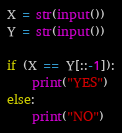Convert code to text. <code><loc_0><loc_0><loc_500><loc_500><_Python_>X = str(input())
Y = str(input())

if (X == Y[::-1]):
    print("YES")
else:
    print("NO")
</code> 